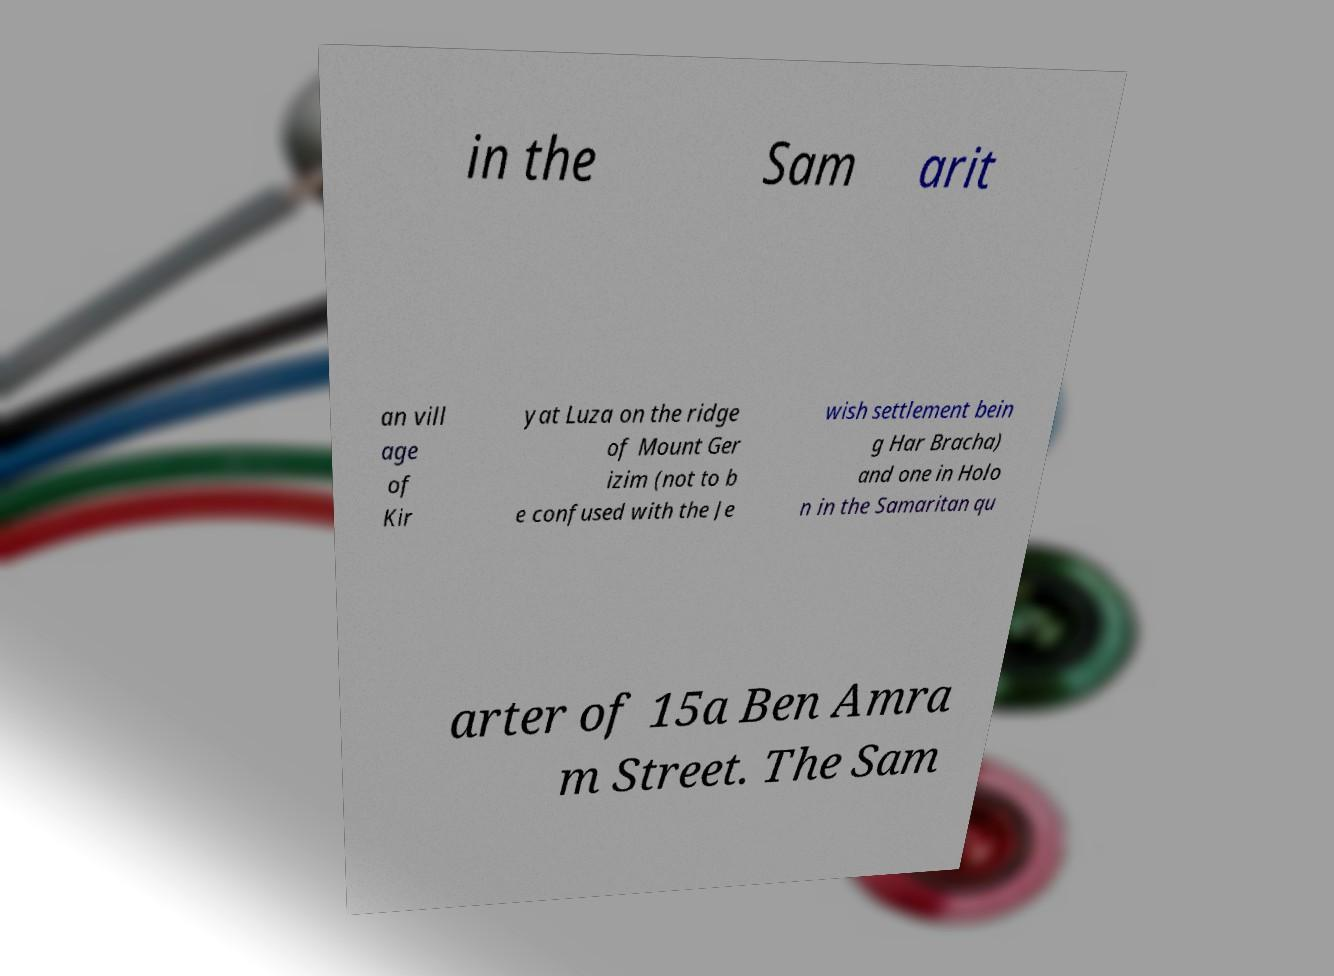I need the written content from this picture converted into text. Can you do that? in the Sam arit an vill age of Kir yat Luza on the ridge of Mount Ger izim (not to b e confused with the Je wish settlement bein g Har Bracha) and one in Holo n in the Samaritan qu arter of 15a Ben Amra m Street. The Sam 